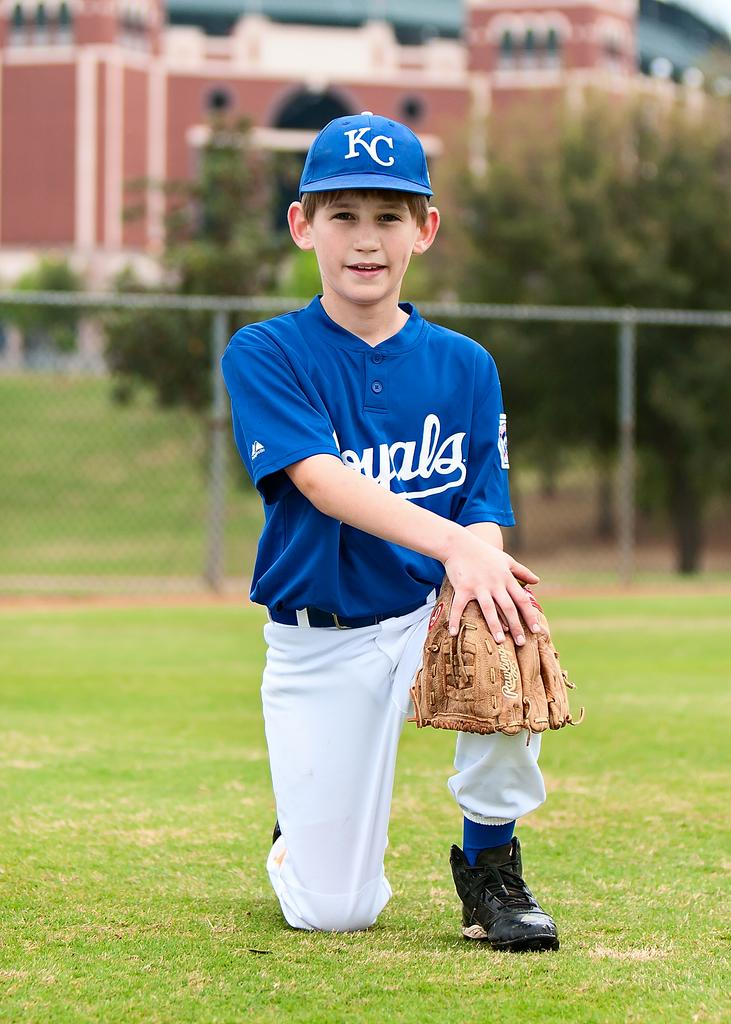Provide a one-sentence caption for the provided image. A boy posing in a baseball uniform with the letters KC on his cap. 